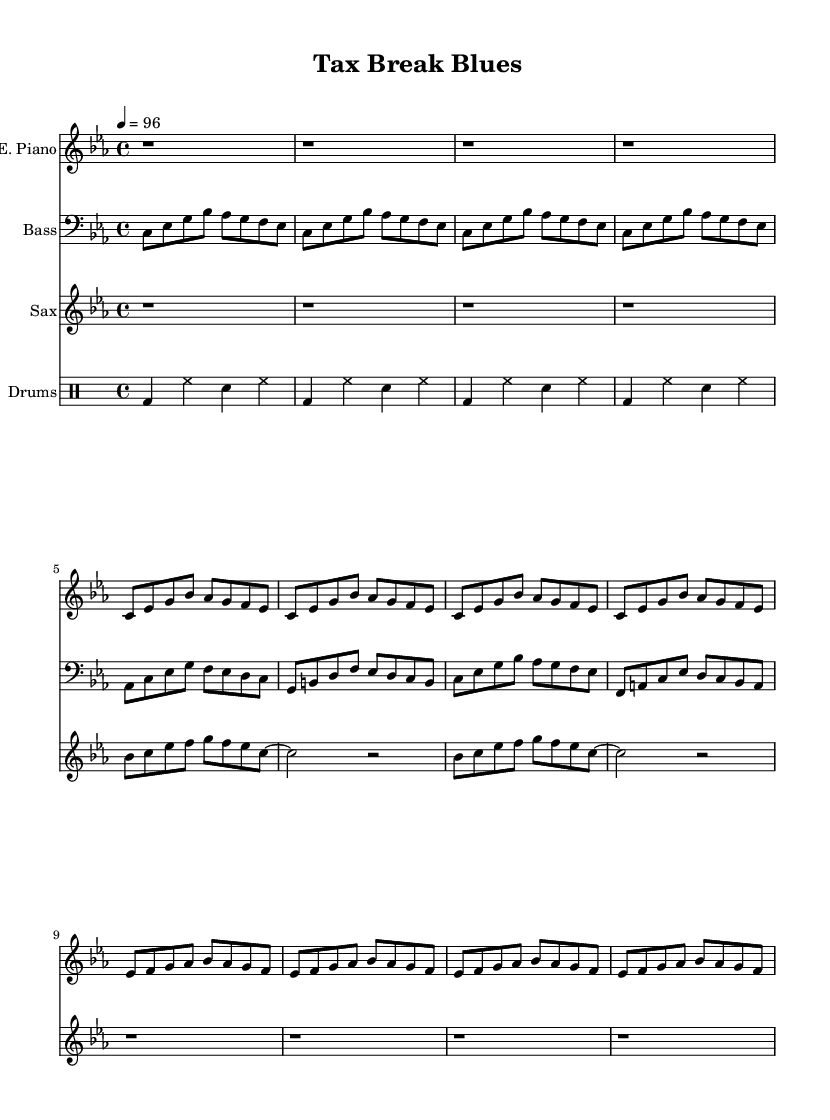What is the key signature of this music? The key signature is C minor, which has three flats (B♭, E♭, A♭). You can determine this from the key signature notation at the beginning of the staff.
Answer: C minor What is the time signature of this music? The time signature is 4/4, indicated at the beginning of the score. This means there are four beats in each measure and the quarter note gets one beat.
Answer: 4/4 What is the tempo marking for this piece? The tempo marking is 96 BPM, shown in the tempo section which indicates the speed of the music—4 beats per minute equals 96 beats.
Answer: 96 How many measures are in the chorus section? The chorus section consists of 4 measures as indicated by the repetitive pattern of notes over that span, repeated 4 times. Each set of notes is contained within a measure, visually separated by vertical lines.
Answer: 4 What instruments are involved in this score? The instruments listed are Electric Piano, Bass, Saxophone, and Drums; this can be identified from the different staves labeled for each instrument.
Answer: Electric Piano, Bass, Saxophone, Drums What type of rhythmic pattern do the drums follow? The drums follow a basic pattern of bass, hi-hat, and snare, indicated by the drum notation that repeats every measure. This basic drum groove is characteristic of funk music, providing a consistent rhythm throughout.
Answer: Basic pattern What characteristic structure is seen in the verse section? The verse section features a repeating riff that consists of eight notes, highlighting the syncopation and groove that are essential in funk. This structure establishes a laid-back feel after the introduction.
Answer: Repeating riff 